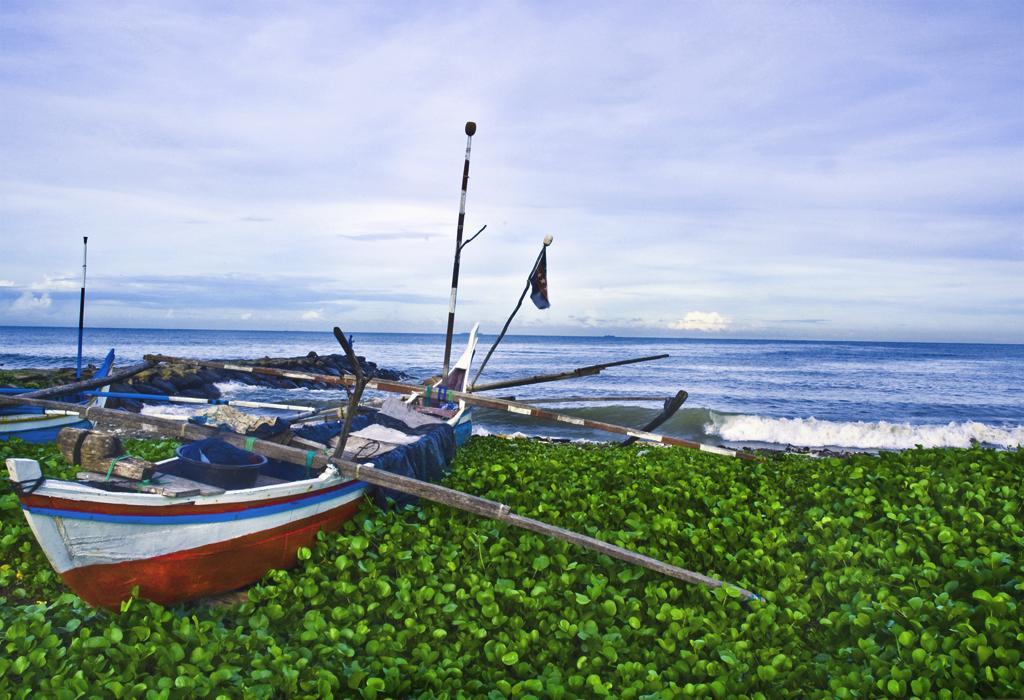Could you give a brief overview of what you see in this image? In this picture we can see a few green plants from left to right. We can see a boat. There is a wooden pole, dish, rope and other objects on a boat. We can see a wooden pole and another boat on the left side. Waves are visible in the water. Sky is cloudy. 